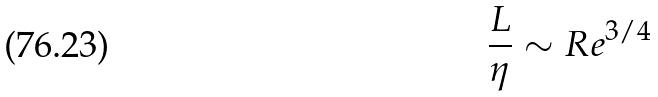<formula> <loc_0><loc_0><loc_500><loc_500>\frac { L } { \eta } \sim R e ^ { 3 / 4 }</formula> 